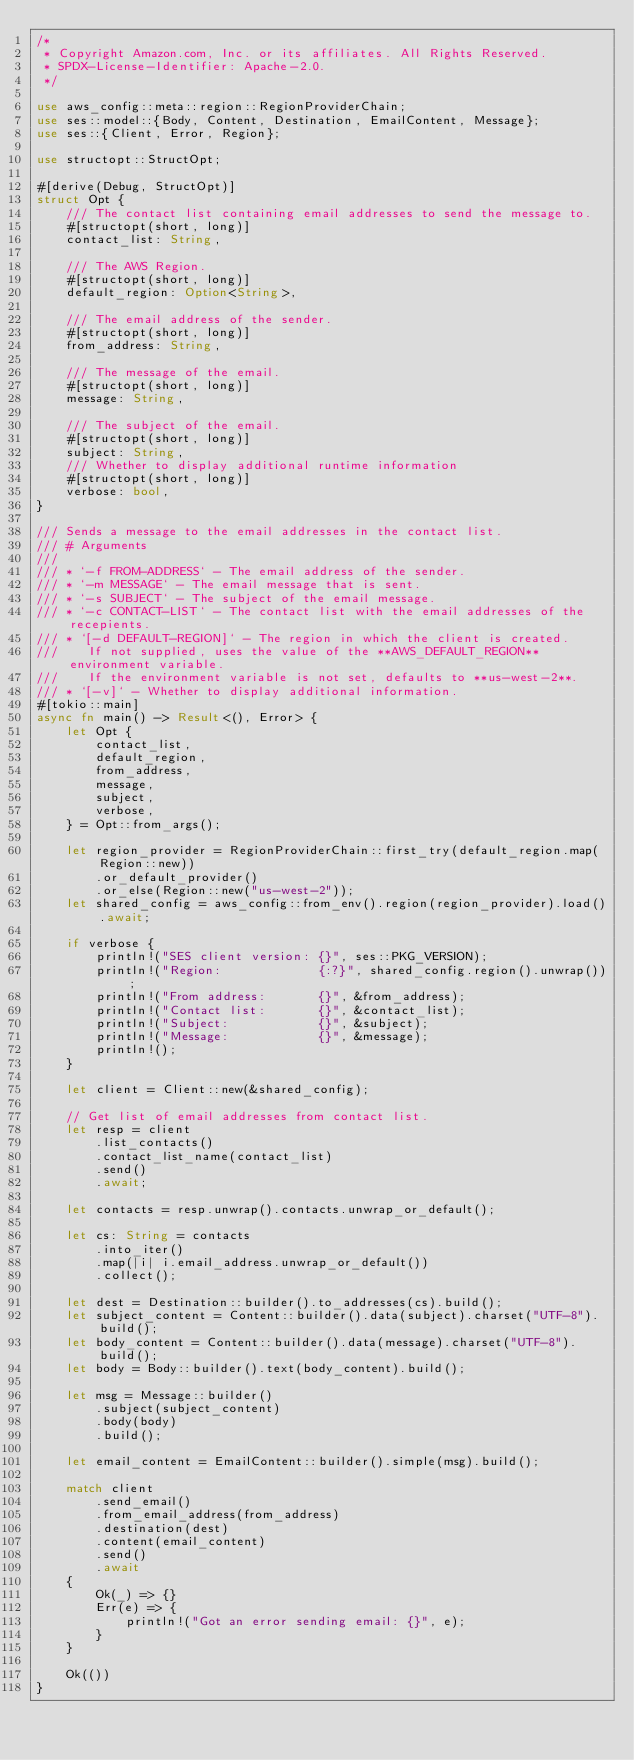Convert code to text. <code><loc_0><loc_0><loc_500><loc_500><_Rust_>/*
 * Copyright Amazon.com, Inc. or its affiliates. All Rights Reserved.
 * SPDX-License-Identifier: Apache-2.0.
 */

use aws_config::meta::region::RegionProviderChain;
use ses::model::{Body, Content, Destination, EmailContent, Message};
use ses::{Client, Error, Region};

use structopt::StructOpt;

#[derive(Debug, StructOpt)]
struct Opt {
    /// The contact list containing email addresses to send the message to.
    #[structopt(short, long)]
    contact_list: String,

    /// The AWS Region.
    #[structopt(short, long)]
    default_region: Option<String>,

    /// The email address of the sender.
    #[structopt(short, long)]
    from_address: String,

    /// The message of the email.
    #[structopt(short, long)]
    message: String,

    /// The subject of the email.
    #[structopt(short, long)]
    subject: String,
    /// Whether to display additional runtime information
    #[structopt(short, long)]
    verbose: bool,
}

/// Sends a message to the email addresses in the contact list.
/// # Arguments
///
/// * `-f FROM-ADDRESS` - The email address of the sender.
/// * `-m MESSAGE` - The email message that is sent.
/// * `-s SUBJECT` - The subject of the email message.
/// * `-c CONTACT-LIST` - The contact list with the email addresses of the recepients.
/// * `[-d DEFAULT-REGION]` - The region in which the client is created.
///    If not supplied, uses the value of the **AWS_DEFAULT_REGION** environment variable.
///    If the environment variable is not set, defaults to **us-west-2**.
/// * `[-v]` - Whether to display additional information.
#[tokio::main]
async fn main() -> Result<(), Error> {
    let Opt {
        contact_list,
        default_region,
        from_address,
        message,
        subject,
        verbose,
    } = Opt::from_args();

    let region_provider = RegionProviderChain::first_try(default_region.map(Region::new))
        .or_default_provider()
        .or_else(Region::new("us-west-2"));
    let shared_config = aws_config::from_env().region(region_provider).load().await;

    if verbose {
        println!("SES client version: {}", ses::PKG_VERSION);
        println!("Region:             {:?}", shared_config.region().unwrap());
        println!("From address:       {}", &from_address);
        println!("Contact list:       {}", &contact_list);
        println!("Subject:            {}", &subject);
        println!("Message:            {}", &message);
        println!();
    }

    let client = Client::new(&shared_config);

    // Get list of email addresses from contact list.
    let resp = client
        .list_contacts()
        .contact_list_name(contact_list)
        .send()
        .await;

    let contacts = resp.unwrap().contacts.unwrap_or_default();

    let cs: String = contacts
        .into_iter()
        .map(|i| i.email_address.unwrap_or_default())
        .collect();

    let dest = Destination::builder().to_addresses(cs).build();
    let subject_content = Content::builder().data(subject).charset("UTF-8").build();
    let body_content = Content::builder().data(message).charset("UTF-8").build();
    let body = Body::builder().text(body_content).build();

    let msg = Message::builder()
        .subject(subject_content)
        .body(body)
        .build();

    let email_content = EmailContent::builder().simple(msg).build();

    match client
        .send_email()
        .from_email_address(from_address)
        .destination(dest)
        .content(email_content)
        .send()
        .await
    {
        Ok(_) => {}
        Err(e) => {
            println!("Got an error sending email: {}", e);
        }
    }

    Ok(())
}
</code> 